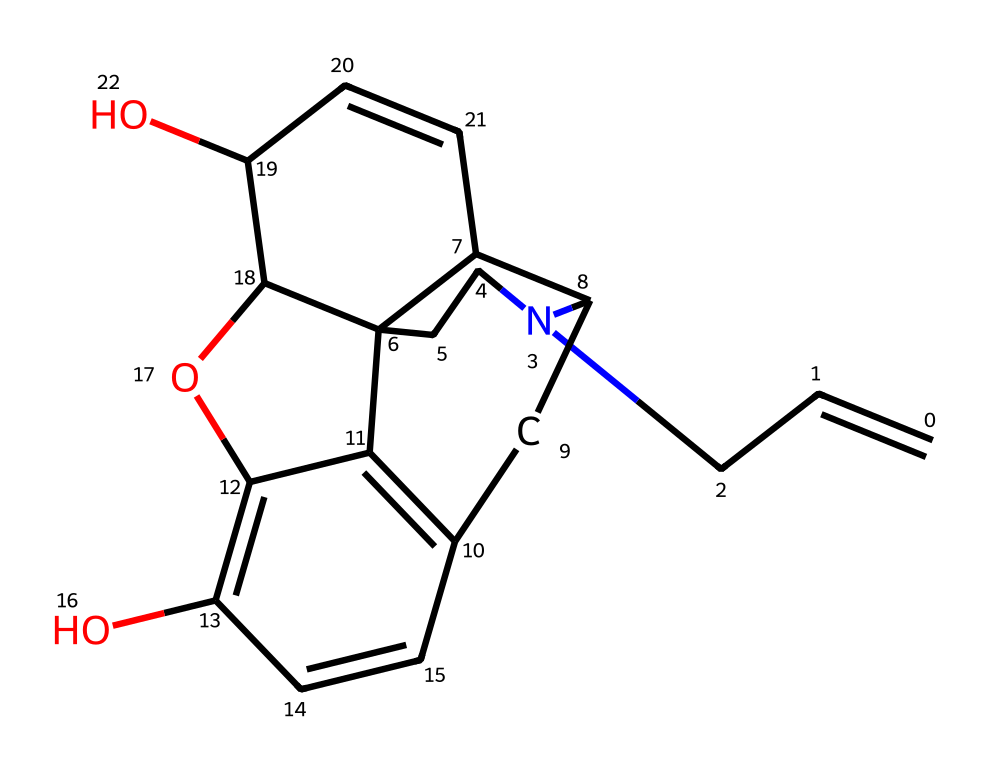What is the molecular formula of naloxone? To determine the molecular formula from the SMILES notation, identify the atoms and their counts: C for carbon, H for hydrogen, N for nitrogen, and O for oxygen. The SMILES indicates 17 carbons, 19 hydrogens, 1 nitrogen, and 2 oxygens. Therefore, the molecular formula is C17H19N2O2.
Answer: C17H19N2O2 How many rings are present in the structure of naloxone? Analyzing the structure reveals that there are multiple cyclized segments. Counting the rings gives a total of 5 distinct rings formed within the compound.
Answer: 5 What functional groups are present in naloxone? Inspecting the chemical structure, naloxone contains hydroxyl (-OH) groups and an amine (-NH) group as evident from the presence of oxygen and nitrogen atoms with their respective connectivity.
Answer: hydroxyl and amine Does naloxone contain any stereocenters? A stereocenter is a carbon atom bonded to four different groups. Analyzing the structure, there are indeed several carbon atoms connected to distinct groups, confirming the presence of stereocenters in the molecule.
Answer: yes What type of medicinal compound is naloxone classified as? Naloxone is primarily used for its capability to reverse opioid effects, categorizing it within opioid antagonists, which are specialized compounds designed to counteract opioid toxicity.
Answer: opioid antagonist 